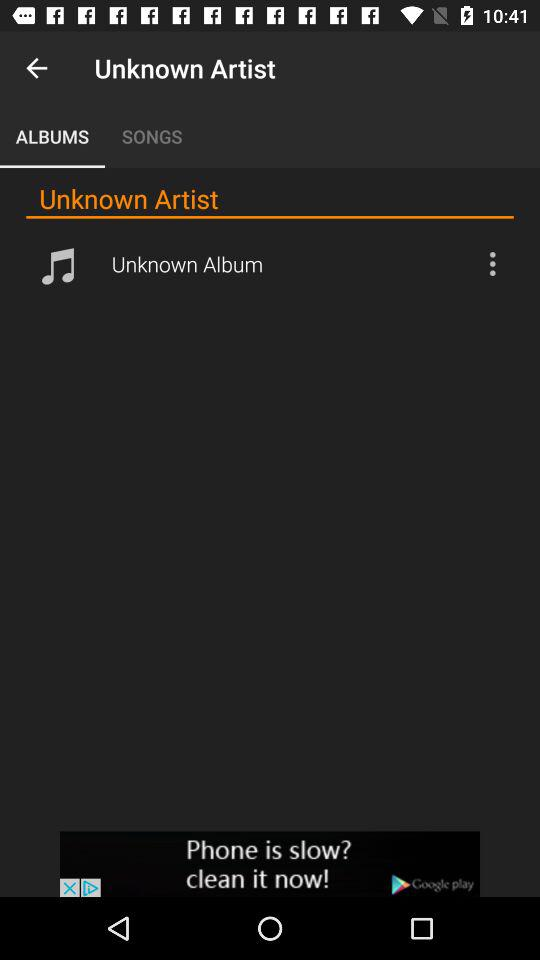Which tab is selected? The selected tab is "ALBUMS". 